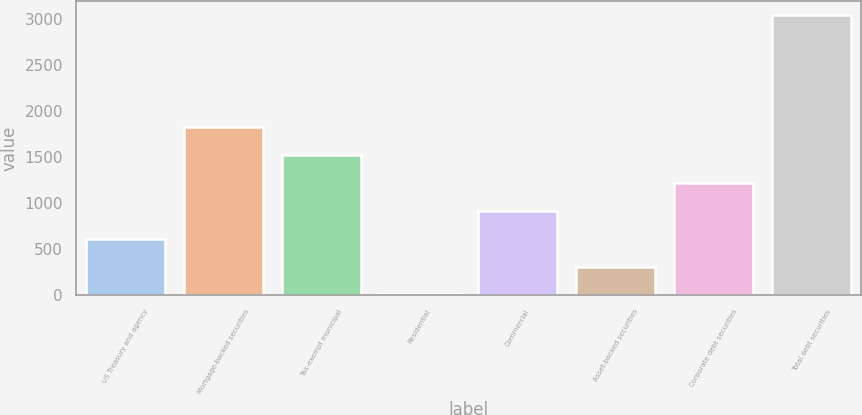Convert chart to OTSL. <chart><loc_0><loc_0><loc_500><loc_500><bar_chart><fcel>US Treasury and agency<fcel>Mortgage-backed securities<fcel>Tax-exempt municipal<fcel>Residential<fcel>Commercial<fcel>Asset-backed securities<fcel>Corporate debt securities<fcel>Total debt securities<nl><fcel>614.8<fcel>1830.4<fcel>1526.5<fcel>7<fcel>918.7<fcel>310.9<fcel>1222.6<fcel>3046<nl></chart> 